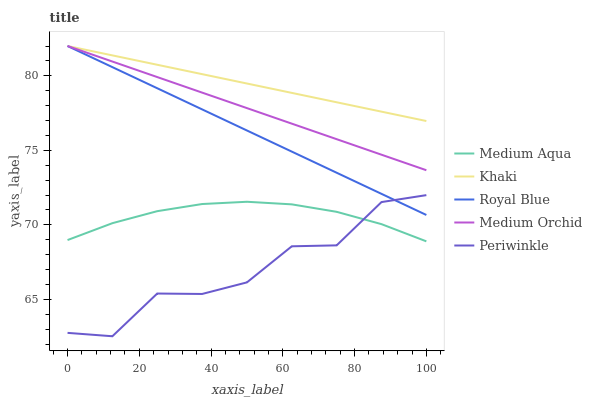Does Periwinkle have the minimum area under the curve?
Answer yes or no. Yes. Does Khaki have the maximum area under the curve?
Answer yes or no. Yes. Does Royal Blue have the minimum area under the curve?
Answer yes or no. No. Does Royal Blue have the maximum area under the curve?
Answer yes or no. No. Is Medium Orchid the smoothest?
Answer yes or no. Yes. Is Periwinkle the roughest?
Answer yes or no. Yes. Is Royal Blue the smoothest?
Answer yes or no. No. Is Royal Blue the roughest?
Answer yes or no. No. Does Periwinkle have the lowest value?
Answer yes or no. Yes. Does Royal Blue have the lowest value?
Answer yes or no. No. Does Khaki have the highest value?
Answer yes or no. Yes. Does Medium Aqua have the highest value?
Answer yes or no. No. Is Medium Aqua less than Medium Orchid?
Answer yes or no. Yes. Is Khaki greater than Medium Aqua?
Answer yes or no. Yes. Does Khaki intersect Medium Orchid?
Answer yes or no. Yes. Is Khaki less than Medium Orchid?
Answer yes or no. No. Is Khaki greater than Medium Orchid?
Answer yes or no. No. Does Medium Aqua intersect Medium Orchid?
Answer yes or no. No. 